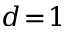<formula> <loc_0><loc_0><loc_500><loc_500>d \, = \, 1</formula> 